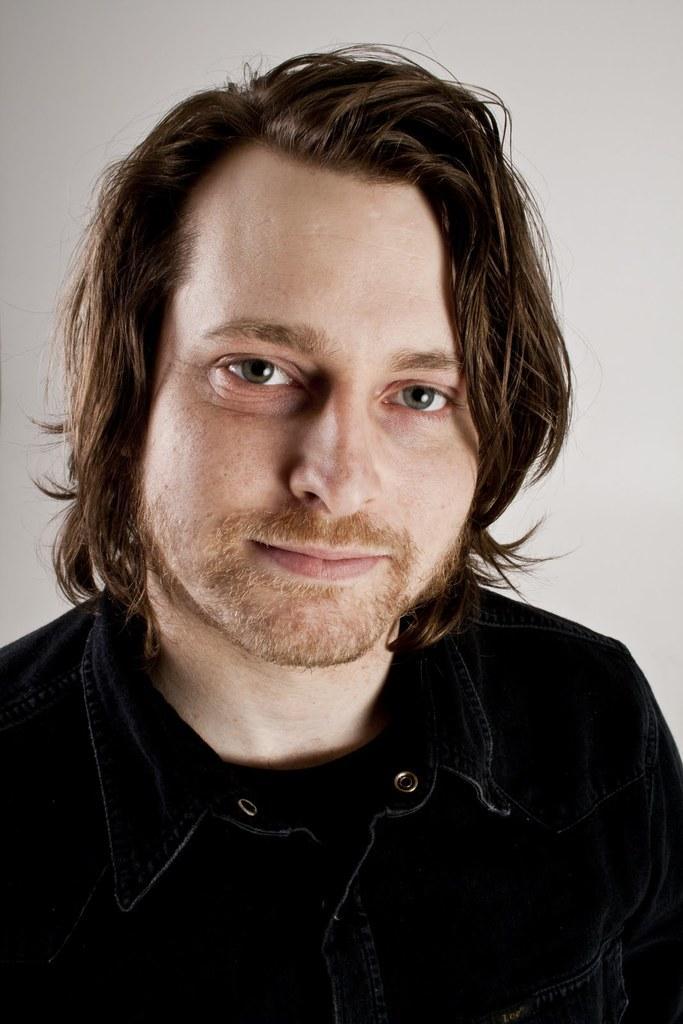Describe this image in one or two sentences. In the foreground of this image, there is a man in black shirt. In the background, there is a white wall. 